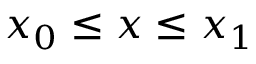<formula> <loc_0><loc_0><loc_500><loc_500>x _ { 0 } \leq x \leq x _ { 1 }</formula> 